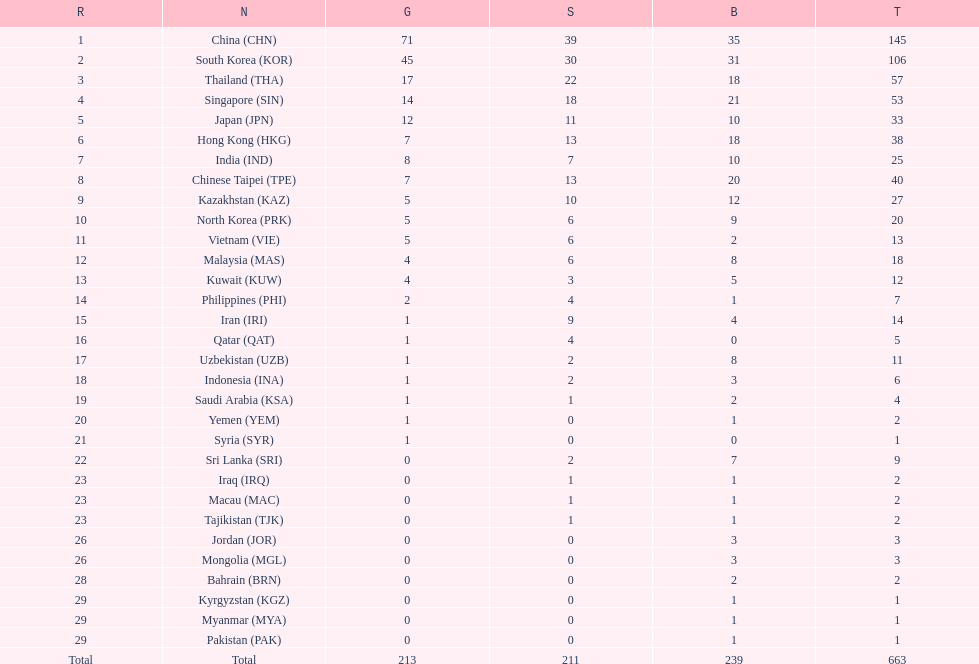Which nation has more gold medals, kuwait or india? India (IND). 